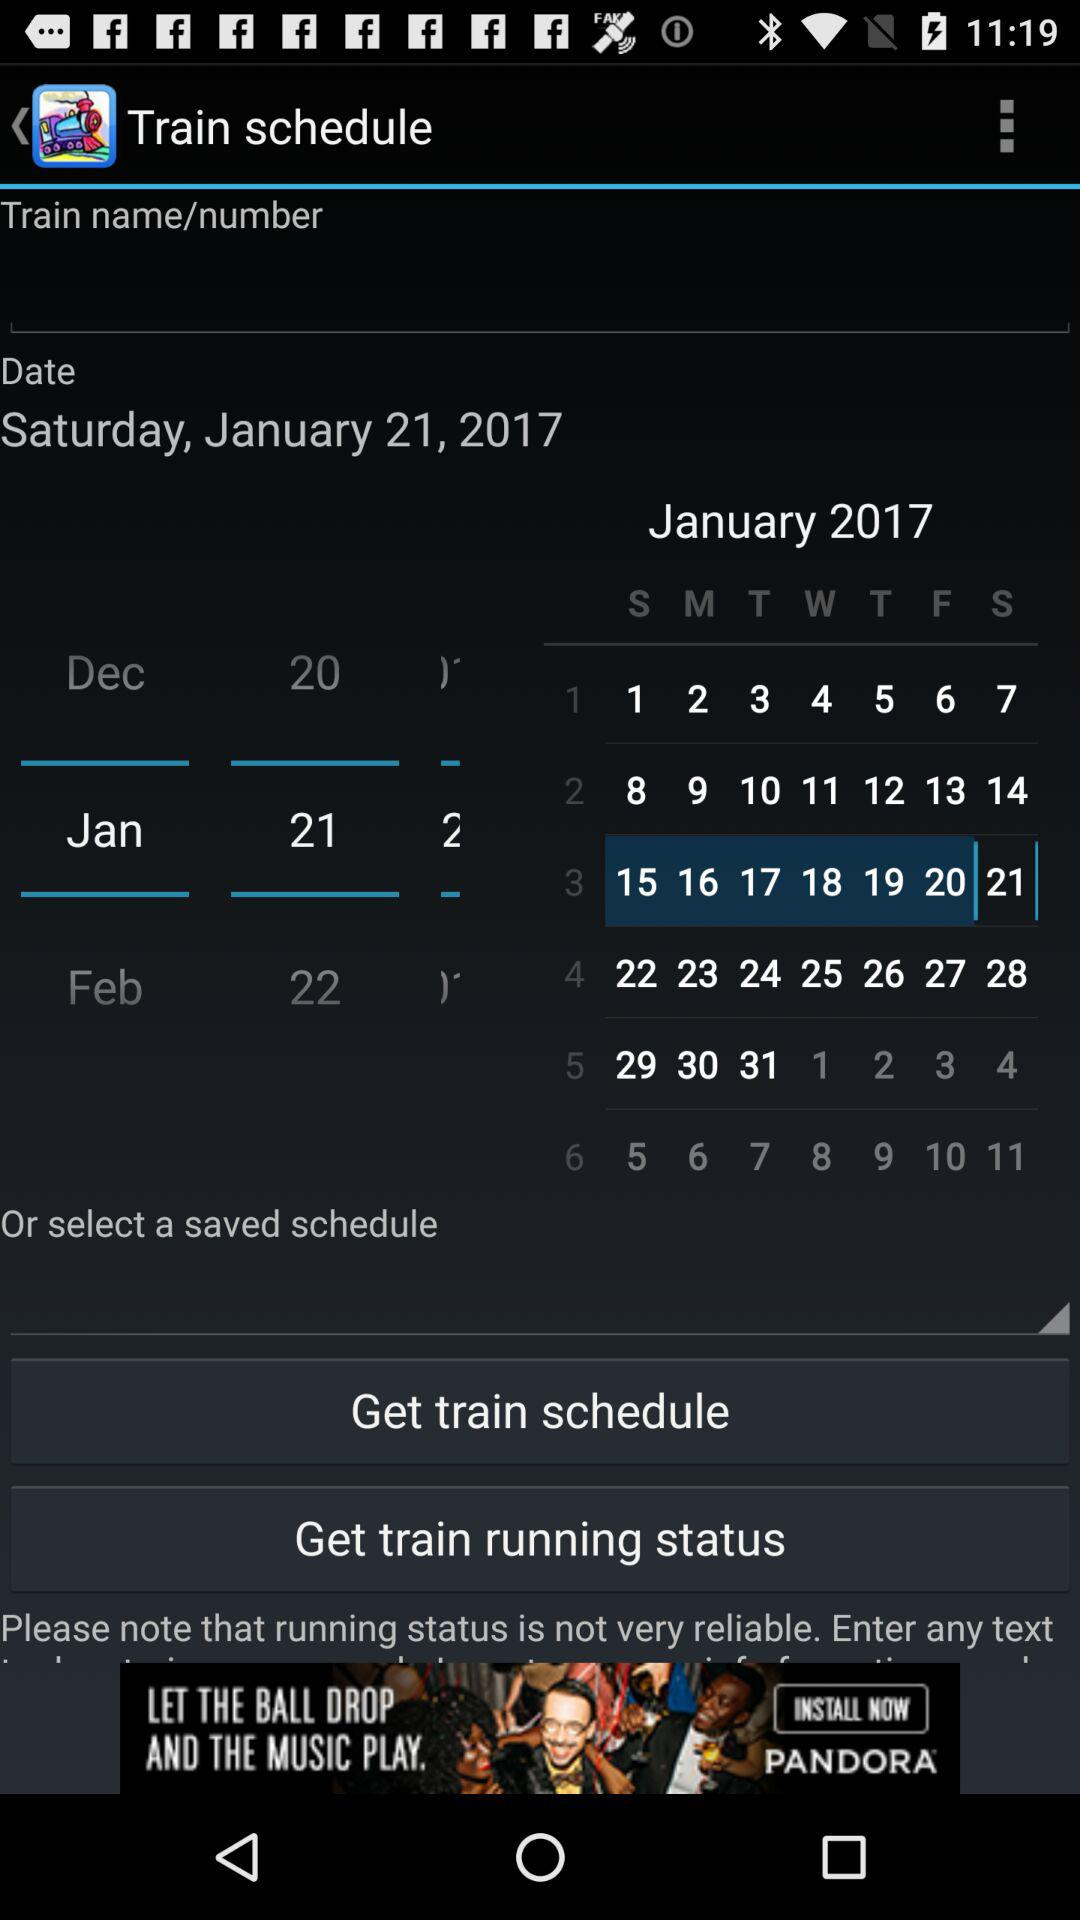What is the selected date? The selected date is Saturday, January 21, 2017. 